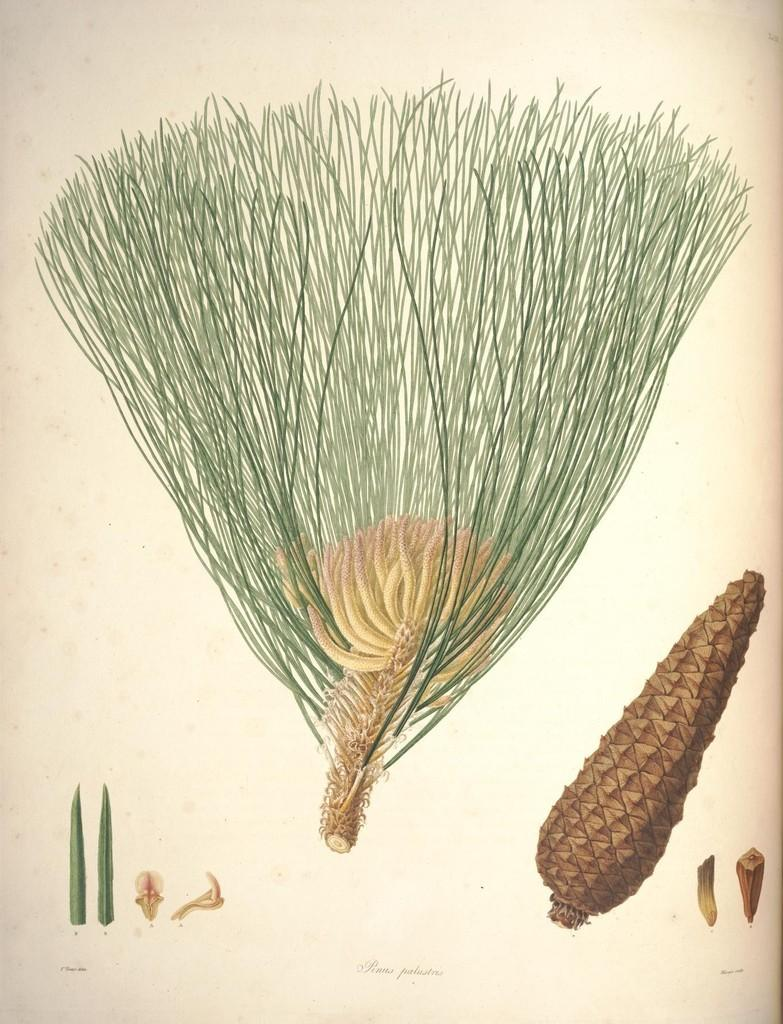What type of plant is in the image? There is a grass plant in the image. Can you describe any specific parts of the plant that are visible? Plant parts are visible at the bottom of the image. Can you see a bee buzzing around the grass plant in the image? There is no bee visible in the image; it only features a grass plant and plant parts at the bottom. 